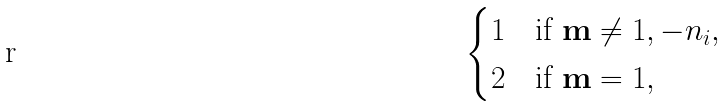<formula> <loc_0><loc_0><loc_500><loc_500>\begin{cases} 1 & \text {if } \mathbf m \ne 1 , - n _ { i } , \\ 2 & \text {if } \mathbf m = 1 , \end{cases}</formula> 